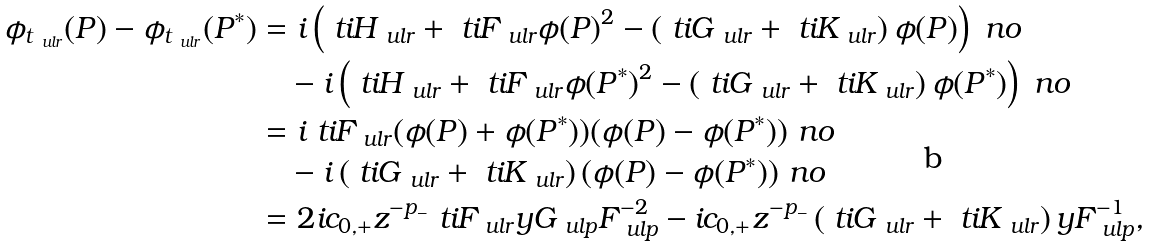Convert formula to latex. <formula><loc_0><loc_0><loc_500><loc_500>\phi _ { t _ { \ u l r } } ( P ) - \phi _ { t _ { \ u l r } } ( P ^ { * } ) & = i \left ( \ t i H _ { \ u l r } + \ t i F _ { \ u l r } \phi ( P ) ^ { 2 } - \left ( \ t i G _ { \ u l r } + \ t i K _ { \ u l r } \right ) \phi ( P ) \right ) \ n o \\ & \quad - i \left ( \ t i H _ { \ u l r } + \ t i F _ { \ u l r } \phi ( P ^ { * } ) ^ { 2 } - \left ( \ t i G _ { \ u l r } + \ t i K _ { \ u l r } \right ) \phi ( P ^ { * } ) \right ) \ n o \\ & = i \ t i F _ { \ u l r } ( \phi ( P ) + \phi ( P ^ { * } ) ) ( \phi ( P ) - \phi ( P ^ { * } ) ) \ n o \\ & \quad - i \left ( \ t i G _ { \ u l r } + \ t i K _ { \ u l r } \right ) ( \phi ( P ) - \phi ( P ^ { * } ) ) \ n o \\ & = 2 i c _ { 0 , + } z ^ { - p _ { - } } \ t i F _ { \ u l r } y G _ { \ u l p } F _ { \ u l p } ^ { - 2 } - i c _ { 0 , + } z ^ { - p _ { - } } \left ( \ t i G _ { \ u l r } + \ t i K _ { \ u l r } \right ) y F _ { \ u l p } ^ { - 1 } ,</formula> 